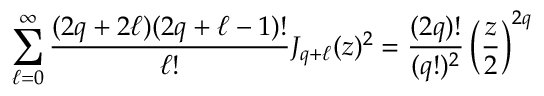Convert formula to latex. <formula><loc_0><loc_0><loc_500><loc_500>\sum _ { \ell = 0 } ^ { \infty } \frac { ( 2 q + 2 \ell ) ( 2 q + \ell - 1 ) ! } { \ell ! } J _ { q + \ell } ( z ) ^ { 2 } = \frac { ( 2 q ) ! } { ( q ! ) ^ { 2 } } \left ( \frac { z } { 2 } \right ) ^ { 2 q }</formula> 